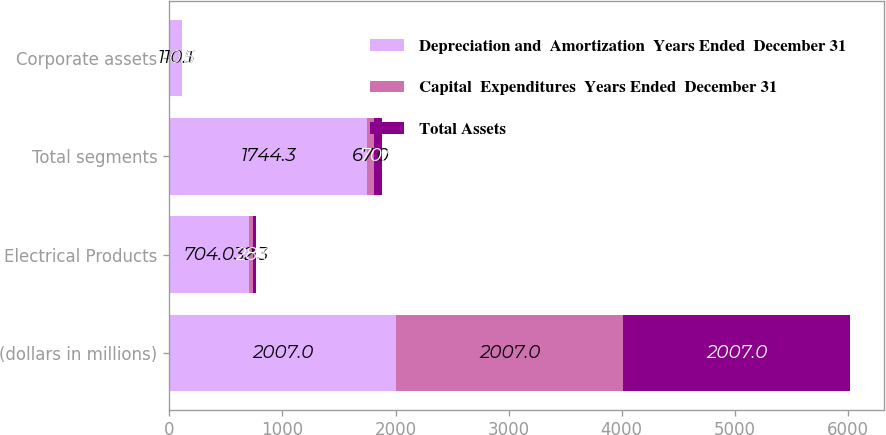<chart> <loc_0><loc_0><loc_500><loc_500><stacked_bar_chart><ecel><fcel>(dollars in millions)<fcel>Electrical Products<fcel>Total segments<fcel>Corporate assets<nl><fcel>Depreciation and  Amortization  Years Ended  December 31<fcel>2007<fcel>704<fcel>1744.3<fcel>110.1<nl><fcel>Capital  Expenditures  Years Ended  December 31<fcel>2007<fcel>32.3<fcel>67<fcel>0.5<nl><fcel>Total Assets<fcel>2007<fcel>28.6<fcel>70.9<fcel>0.5<nl></chart> 